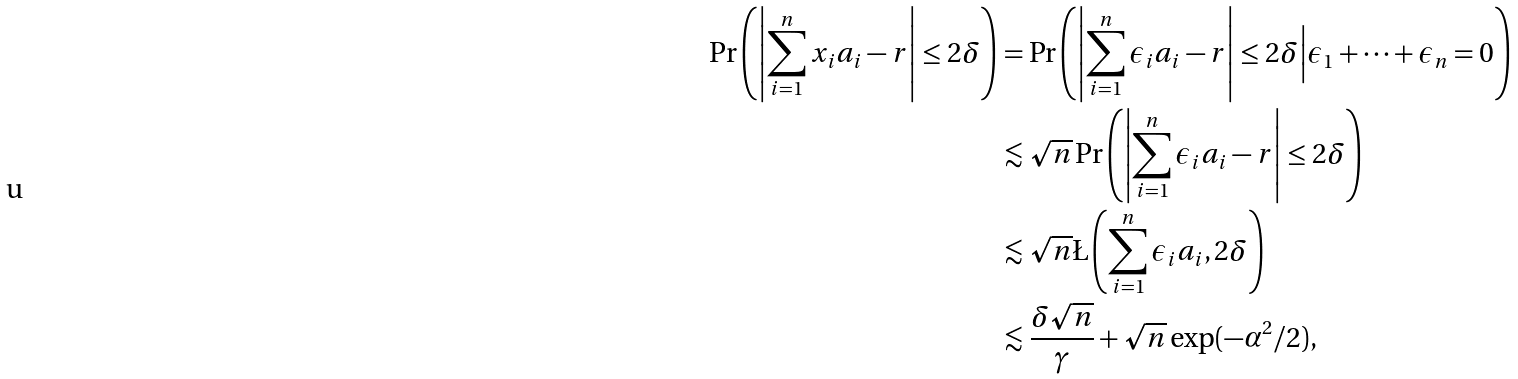<formula> <loc_0><loc_0><loc_500><loc_500>\Pr \left ( \left | \sum _ { i = 1 } ^ { n } x _ { i } a _ { i } - r \right | \leq 2 \delta \right ) & = \Pr \left ( \left | \sum _ { i = 1 } ^ { n } \epsilon _ { i } a _ { i } - r \right | \leq 2 \delta \Big | \epsilon _ { 1 } + \dots + \epsilon _ { n } = 0 \right ) \\ & \lesssim \sqrt { n } \Pr \left ( \left | \sum _ { i = 1 } ^ { n } \epsilon _ { i } a _ { i } - r \right | \leq 2 \delta \right ) \\ & \lesssim \sqrt { n } \L \left ( \sum _ { i = 1 } ^ { n } \epsilon _ { i } a _ { i } , 2 \delta \right ) \\ & \lesssim \frac { \delta \sqrt { n } } { \gamma } + \sqrt { n } \exp ( - \alpha ^ { 2 } / 2 ) ,</formula> 